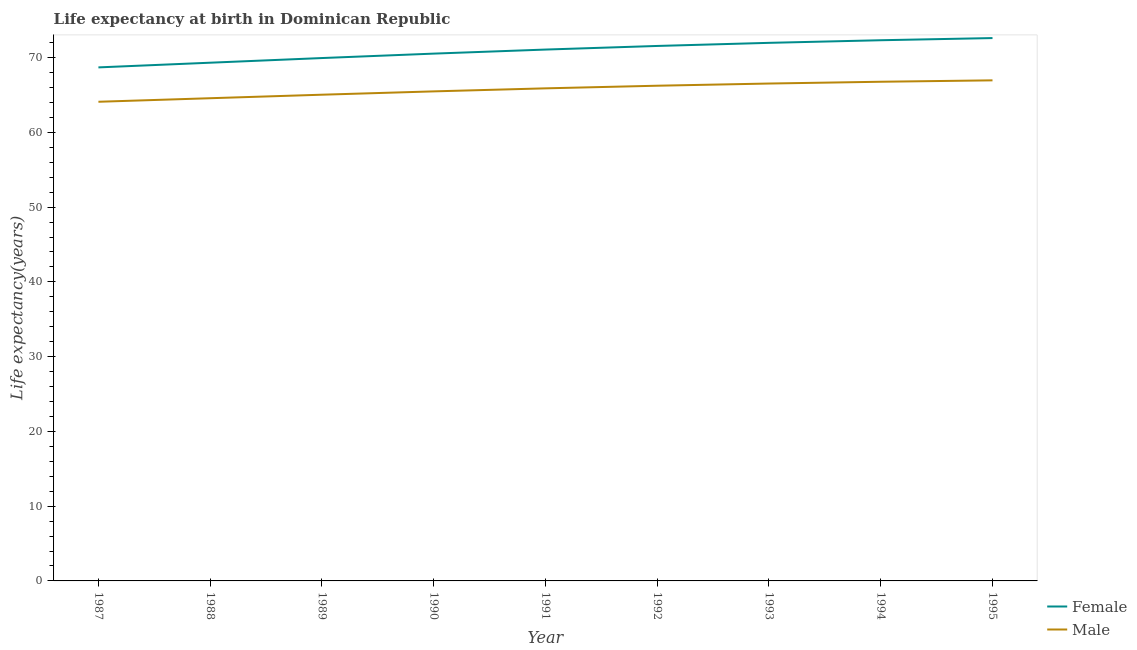How many different coloured lines are there?
Give a very brief answer. 2. Does the line corresponding to life expectancy(male) intersect with the line corresponding to life expectancy(female)?
Offer a terse response. No. What is the life expectancy(female) in 1990?
Make the answer very short. 70.54. Across all years, what is the maximum life expectancy(female)?
Your answer should be very brief. 72.62. Across all years, what is the minimum life expectancy(male)?
Make the answer very short. 64.1. What is the total life expectancy(male) in the graph?
Provide a succinct answer. 591.6. What is the difference between the life expectancy(female) in 1987 and that in 1990?
Keep it short and to the point. -1.84. What is the difference between the life expectancy(male) in 1991 and the life expectancy(female) in 1995?
Your answer should be very brief. -6.73. What is the average life expectancy(female) per year?
Offer a very short reply. 70.9. In the year 1991, what is the difference between the life expectancy(male) and life expectancy(female)?
Offer a very short reply. -5.19. In how many years, is the life expectancy(female) greater than 52 years?
Provide a short and direct response. 9. What is the ratio of the life expectancy(female) in 1987 to that in 1992?
Your answer should be compact. 0.96. Is the life expectancy(female) in 1987 less than that in 1993?
Offer a very short reply. Yes. What is the difference between the highest and the second highest life expectancy(female)?
Give a very brief answer. 0.29. What is the difference between the highest and the lowest life expectancy(female)?
Offer a very short reply. 3.92. In how many years, is the life expectancy(male) greater than the average life expectancy(male) taken over all years?
Give a very brief answer. 5. Is the life expectancy(female) strictly greater than the life expectancy(male) over the years?
Your answer should be very brief. Yes. How many years are there in the graph?
Provide a succinct answer. 9. What is the difference between two consecutive major ticks on the Y-axis?
Ensure brevity in your answer.  10. Does the graph contain any zero values?
Your response must be concise. No. Does the graph contain grids?
Keep it short and to the point. No. Where does the legend appear in the graph?
Keep it short and to the point. Bottom right. How many legend labels are there?
Keep it short and to the point. 2. What is the title of the graph?
Provide a succinct answer. Life expectancy at birth in Dominican Republic. What is the label or title of the X-axis?
Keep it short and to the point. Year. What is the label or title of the Y-axis?
Offer a terse response. Life expectancy(years). What is the Life expectancy(years) of Female in 1987?
Make the answer very short. 68.69. What is the Life expectancy(years) of Male in 1987?
Your answer should be compact. 64.1. What is the Life expectancy(years) of Female in 1988?
Provide a short and direct response. 69.32. What is the Life expectancy(years) in Male in 1988?
Provide a short and direct response. 64.57. What is the Life expectancy(years) in Female in 1989?
Offer a very short reply. 69.94. What is the Life expectancy(years) in Male in 1989?
Offer a terse response. 65.04. What is the Life expectancy(years) of Female in 1990?
Your response must be concise. 70.54. What is the Life expectancy(years) of Male in 1990?
Offer a terse response. 65.49. What is the Life expectancy(years) in Female in 1991?
Provide a succinct answer. 71.08. What is the Life expectancy(years) in Male in 1991?
Provide a succinct answer. 65.89. What is the Life expectancy(years) in Female in 1992?
Ensure brevity in your answer.  71.56. What is the Life expectancy(years) in Male in 1992?
Provide a short and direct response. 66.24. What is the Life expectancy(years) of Female in 1993?
Provide a short and direct response. 71.98. What is the Life expectancy(years) in Male in 1993?
Ensure brevity in your answer.  66.54. What is the Life expectancy(years) in Female in 1994?
Provide a short and direct response. 72.33. What is the Life expectancy(years) in Male in 1994?
Offer a terse response. 66.77. What is the Life expectancy(years) of Female in 1995?
Keep it short and to the point. 72.62. What is the Life expectancy(years) of Male in 1995?
Your answer should be compact. 66.96. Across all years, what is the maximum Life expectancy(years) of Female?
Make the answer very short. 72.62. Across all years, what is the maximum Life expectancy(years) in Male?
Offer a very short reply. 66.96. Across all years, what is the minimum Life expectancy(years) of Female?
Provide a short and direct response. 68.69. Across all years, what is the minimum Life expectancy(years) of Male?
Your answer should be compact. 64.1. What is the total Life expectancy(years) in Female in the graph?
Ensure brevity in your answer.  638.06. What is the total Life expectancy(years) of Male in the graph?
Your response must be concise. 591.6. What is the difference between the Life expectancy(years) in Female in 1987 and that in 1988?
Offer a terse response. -0.63. What is the difference between the Life expectancy(years) of Male in 1987 and that in 1988?
Keep it short and to the point. -0.47. What is the difference between the Life expectancy(years) in Female in 1987 and that in 1989?
Offer a terse response. -1.25. What is the difference between the Life expectancy(years) in Male in 1987 and that in 1989?
Offer a very short reply. -0.94. What is the difference between the Life expectancy(years) of Female in 1987 and that in 1990?
Provide a succinct answer. -1.84. What is the difference between the Life expectancy(years) of Male in 1987 and that in 1990?
Provide a short and direct response. -1.39. What is the difference between the Life expectancy(years) of Female in 1987 and that in 1991?
Your response must be concise. -2.39. What is the difference between the Life expectancy(years) of Male in 1987 and that in 1991?
Offer a very short reply. -1.79. What is the difference between the Life expectancy(years) in Female in 1987 and that in 1992?
Provide a succinct answer. -2.87. What is the difference between the Life expectancy(years) of Male in 1987 and that in 1992?
Your answer should be compact. -2.15. What is the difference between the Life expectancy(years) of Female in 1987 and that in 1993?
Give a very brief answer. -3.28. What is the difference between the Life expectancy(years) of Male in 1987 and that in 1993?
Your answer should be compact. -2.44. What is the difference between the Life expectancy(years) of Female in 1987 and that in 1994?
Keep it short and to the point. -3.63. What is the difference between the Life expectancy(years) in Male in 1987 and that in 1994?
Your answer should be compact. -2.68. What is the difference between the Life expectancy(years) of Female in 1987 and that in 1995?
Your answer should be very brief. -3.92. What is the difference between the Life expectancy(years) of Male in 1987 and that in 1995?
Your answer should be very brief. -2.87. What is the difference between the Life expectancy(years) of Female in 1988 and that in 1989?
Give a very brief answer. -0.62. What is the difference between the Life expectancy(years) of Male in 1988 and that in 1989?
Make the answer very short. -0.47. What is the difference between the Life expectancy(years) of Female in 1988 and that in 1990?
Provide a succinct answer. -1.22. What is the difference between the Life expectancy(years) in Male in 1988 and that in 1990?
Offer a terse response. -0.92. What is the difference between the Life expectancy(years) in Female in 1988 and that in 1991?
Provide a short and direct response. -1.76. What is the difference between the Life expectancy(years) in Male in 1988 and that in 1991?
Your response must be concise. -1.32. What is the difference between the Life expectancy(years) of Female in 1988 and that in 1992?
Keep it short and to the point. -2.24. What is the difference between the Life expectancy(years) in Male in 1988 and that in 1992?
Your answer should be compact. -1.67. What is the difference between the Life expectancy(years) of Female in 1988 and that in 1993?
Make the answer very short. -2.66. What is the difference between the Life expectancy(years) in Male in 1988 and that in 1993?
Ensure brevity in your answer.  -1.97. What is the difference between the Life expectancy(years) of Female in 1988 and that in 1994?
Provide a short and direct response. -3.01. What is the difference between the Life expectancy(years) of Male in 1988 and that in 1994?
Your answer should be very brief. -2.2. What is the difference between the Life expectancy(years) of Female in 1988 and that in 1995?
Provide a short and direct response. -3.3. What is the difference between the Life expectancy(years) in Male in 1988 and that in 1995?
Ensure brevity in your answer.  -2.39. What is the difference between the Life expectancy(years) in Female in 1989 and that in 1990?
Give a very brief answer. -0.59. What is the difference between the Life expectancy(years) in Male in 1989 and that in 1990?
Provide a short and direct response. -0.45. What is the difference between the Life expectancy(years) of Female in 1989 and that in 1991?
Offer a terse response. -1.14. What is the difference between the Life expectancy(years) in Male in 1989 and that in 1991?
Make the answer very short. -0.85. What is the difference between the Life expectancy(years) of Female in 1989 and that in 1992?
Provide a succinct answer. -1.62. What is the difference between the Life expectancy(years) in Male in 1989 and that in 1992?
Your response must be concise. -1.2. What is the difference between the Life expectancy(years) of Female in 1989 and that in 1993?
Ensure brevity in your answer.  -2.03. What is the difference between the Life expectancy(years) of Male in 1989 and that in 1993?
Offer a very short reply. -1.5. What is the difference between the Life expectancy(years) of Female in 1989 and that in 1994?
Provide a succinct answer. -2.38. What is the difference between the Life expectancy(years) of Male in 1989 and that in 1994?
Give a very brief answer. -1.73. What is the difference between the Life expectancy(years) in Female in 1989 and that in 1995?
Your response must be concise. -2.67. What is the difference between the Life expectancy(years) in Male in 1989 and that in 1995?
Keep it short and to the point. -1.92. What is the difference between the Life expectancy(years) in Female in 1990 and that in 1991?
Your response must be concise. -0.54. What is the difference between the Life expectancy(years) in Male in 1990 and that in 1991?
Your answer should be very brief. -0.4. What is the difference between the Life expectancy(years) in Female in 1990 and that in 1992?
Your answer should be compact. -1.02. What is the difference between the Life expectancy(years) in Male in 1990 and that in 1992?
Provide a succinct answer. -0.76. What is the difference between the Life expectancy(years) of Female in 1990 and that in 1993?
Keep it short and to the point. -1.44. What is the difference between the Life expectancy(years) in Male in 1990 and that in 1993?
Your answer should be very brief. -1.05. What is the difference between the Life expectancy(years) in Female in 1990 and that in 1994?
Provide a short and direct response. -1.79. What is the difference between the Life expectancy(years) in Male in 1990 and that in 1994?
Provide a succinct answer. -1.29. What is the difference between the Life expectancy(years) of Female in 1990 and that in 1995?
Your answer should be very brief. -2.08. What is the difference between the Life expectancy(years) in Male in 1990 and that in 1995?
Your answer should be compact. -1.47. What is the difference between the Life expectancy(years) in Female in 1991 and that in 1992?
Your response must be concise. -0.48. What is the difference between the Life expectancy(years) of Male in 1991 and that in 1992?
Provide a short and direct response. -0.35. What is the difference between the Life expectancy(years) of Female in 1991 and that in 1993?
Your answer should be very brief. -0.9. What is the difference between the Life expectancy(years) of Male in 1991 and that in 1993?
Your answer should be very brief. -0.65. What is the difference between the Life expectancy(years) of Female in 1991 and that in 1994?
Give a very brief answer. -1.25. What is the difference between the Life expectancy(years) of Male in 1991 and that in 1994?
Offer a very short reply. -0.88. What is the difference between the Life expectancy(years) of Female in 1991 and that in 1995?
Your answer should be compact. -1.54. What is the difference between the Life expectancy(years) in Male in 1991 and that in 1995?
Your answer should be very brief. -1.07. What is the difference between the Life expectancy(years) of Female in 1992 and that in 1993?
Offer a very short reply. -0.42. What is the difference between the Life expectancy(years) of Male in 1992 and that in 1993?
Provide a succinct answer. -0.29. What is the difference between the Life expectancy(years) of Female in 1992 and that in 1994?
Keep it short and to the point. -0.77. What is the difference between the Life expectancy(years) of Male in 1992 and that in 1994?
Offer a very short reply. -0.53. What is the difference between the Life expectancy(years) of Female in 1992 and that in 1995?
Keep it short and to the point. -1.06. What is the difference between the Life expectancy(years) in Male in 1992 and that in 1995?
Your response must be concise. -0.72. What is the difference between the Life expectancy(years) in Female in 1993 and that in 1994?
Offer a terse response. -0.35. What is the difference between the Life expectancy(years) of Male in 1993 and that in 1994?
Keep it short and to the point. -0.24. What is the difference between the Life expectancy(years) in Female in 1993 and that in 1995?
Give a very brief answer. -0.64. What is the difference between the Life expectancy(years) of Male in 1993 and that in 1995?
Ensure brevity in your answer.  -0.42. What is the difference between the Life expectancy(years) in Female in 1994 and that in 1995?
Ensure brevity in your answer.  -0.29. What is the difference between the Life expectancy(years) of Male in 1994 and that in 1995?
Provide a succinct answer. -0.19. What is the difference between the Life expectancy(years) in Female in 1987 and the Life expectancy(years) in Male in 1988?
Give a very brief answer. 4.12. What is the difference between the Life expectancy(years) of Female in 1987 and the Life expectancy(years) of Male in 1989?
Give a very brief answer. 3.65. What is the difference between the Life expectancy(years) of Female in 1987 and the Life expectancy(years) of Male in 1990?
Offer a very short reply. 3.21. What is the difference between the Life expectancy(years) of Female in 1987 and the Life expectancy(years) of Male in 1991?
Give a very brief answer. 2.8. What is the difference between the Life expectancy(years) of Female in 1987 and the Life expectancy(years) of Male in 1992?
Ensure brevity in your answer.  2.45. What is the difference between the Life expectancy(years) of Female in 1987 and the Life expectancy(years) of Male in 1993?
Offer a very short reply. 2.16. What is the difference between the Life expectancy(years) in Female in 1987 and the Life expectancy(years) in Male in 1994?
Offer a terse response. 1.92. What is the difference between the Life expectancy(years) in Female in 1987 and the Life expectancy(years) in Male in 1995?
Your answer should be very brief. 1.73. What is the difference between the Life expectancy(years) in Female in 1988 and the Life expectancy(years) in Male in 1989?
Ensure brevity in your answer.  4.28. What is the difference between the Life expectancy(years) of Female in 1988 and the Life expectancy(years) of Male in 1990?
Provide a short and direct response. 3.83. What is the difference between the Life expectancy(years) in Female in 1988 and the Life expectancy(years) in Male in 1991?
Give a very brief answer. 3.43. What is the difference between the Life expectancy(years) in Female in 1988 and the Life expectancy(years) in Male in 1992?
Give a very brief answer. 3.08. What is the difference between the Life expectancy(years) of Female in 1988 and the Life expectancy(years) of Male in 1993?
Make the answer very short. 2.79. What is the difference between the Life expectancy(years) in Female in 1988 and the Life expectancy(years) in Male in 1994?
Your answer should be very brief. 2.55. What is the difference between the Life expectancy(years) of Female in 1988 and the Life expectancy(years) of Male in 1995?
Your answer should be very brief. 2.36. What is the difference between the Life expectancy(years) in Female in 1989 and the Life expectancy(years) in Male in 1990?
Make the answer very short. 4.46. What is the difference between the Life expectancy(years) in Female in 1989 and the Life expectancy(years) in Male in 1991?
Your answer should be compact. 4.05. What is the difference between the Life expectancy(years) in Female in 1989 and the Life expectancy(years) in Male in 1992?
Give a very brief answer. 3.7. What is the difference between the Life expectancy(years) in Female in 1989 and the Life expectancy(years) in Male in 1993?
Ensure brevity in your answer.  3.41. What is the difference between the Life expectancy(years) in Female in 1989 and the Life expectancy(years) in Male in 1994?
Your response must be concise. 3.17. What is the difference between the Life expectancy(years) of Female in 1989 and the Life expectancy(years) of Male in 1995?
Give a very brief answer. 2.98. What is the difference between the Life expectancy(years) of Female in 1990 and the Life expectancy(years) of Male in 1991?
Offer a terse response. 4.65. What is the difference between the Life expectancy(years) in Female in 1990 and the Life expectancy(years) in Male in 1992?
Give a very brief answer. 4.29. What is the difference between the Life expectancy(years) of Female in 1990 and the Life expectancy(years) of Male in 1993?
Your answer should be compact. 4. What is the difference between the Life expectancy(years) of Female in 1990 and the Life expectancy(years) of Male in 1994?
Your response must be concise. 3.76. What is the difference between the Life expectancy(years) of Female in 1990 and the Life expectancy(years) of Male in 1995?
Keep it short and to the point. 3.58. What is the difference between the Life expectancy(years) in Female in 1991 and the Life expectancy(years) in Male in 1992?
Provide a succinct answer. 4.84. What is the difference between the Life expectancy(years) of Female in 1991 and the Life expectancy(years) of Male in 1993?
Your response must be concise. 4.54. What is the difference between the Life expectancy(years) of Female in 1991 and the Life expectancy(years) of Male in 1994?
Provide a succinct answer. 4.31. What is the difference between the Life expectancy(years) in Female in 1991 and the Life expectancy(years) in Male in 1995?
Give a very brief answer. 4.12. What is the difference between the Life expectancy(years) in Female in 1992 and the Life expectancy(years) in Male in 1993?
Keep it short and to the point. 5.03. What is the difference between the Life expectancy(years) in Female in 1992 and the Life expectancy(years) in Male in 1994?
Ensure brevity in your answer.  4.79. What is the difference between the Life expectancy(years) in Female in 1992 and the Life expectancy(years) in Male in 1995?
Your answer should be very brief. 4.6. What is the difference between the Life expectancy(years) in Female in 1993 and the Life expectancy(years) in Male in 1994?
Keep it short and to the point. 5.2. What is the difference between the Life expectancy(years) of Female in 1993 and the Life expectancy(years) of Male in 1995?
Offer a terse response. 5.02. What is the difference between the Life expectancy(years) in Female in 1994 and the Life expectancy(years) in Male in 1995?
Provide a short and direct response. 5.37. What is the average Life expectancy(years) in Female per year?
Your response must be concise. 70.9. What is the average Life expectancy(years) of Male per year?
Offer a terse response. 65.73. In the year 1987, what is the difference between the Life expectancy(years) in Female and Life expectancy(years) in Male?
Offer a very short reply. 4.6. In the year 1988, what is the difference between the Life expectancy(years) of Female and Life expectancy(years) of Male?
Your answer should be very brief. 4.75. In the year 1989, what is the difference between the Life expectancy(years) of Female and Life expectancy(years) of Male?
Your response must be concise. 4.9. In the year 1990, what is the difference between the Life expectancy(years) of Female and Life expectancy(years) of Male?
Provide a succinct answer. 5.05. In the year 1991, what is the difference between the Life expectancy(years) of Female and Life expectancy(years) of Male?
Ensure brevity in your answer.  5.19. In the year 1992, what is the difference between the Life expectancy(years) of Female and Life expectancy(years) of Male?
Offer a very short reply. 5.32. In the year 1993, what is the difference between the Life expectancy(years) of Female and Life expectancy(years) of Male?
Make the answer very short. 5.44. In the year 1994, what is the difference between the Life expectancy(years) in Female and Life expectancy(years) in Male?
Provide a short and direct response. 5.55. In the year 1995, what is the difference between the Life expectancy(years) in Female and Life expectancy(years) in Male?
Make the answer very short. 5.66. What is the ratio of the Life expectancy(years) of Female in 1987 to that in 1988?
Your answer should be compact. 0.99. What is the ratio of the Life expectancy(years) in Male in 1987 to that in 1988?
Offer a terse response. 0.99. What is the ratio of the Life expectancy(years) in Female in 1987 to that in 1989?
Make the answer very short. 0.98. What is the ratio of the Life expectancy(years) of Male in 1987 to that in 1989?
Your answer should be very brief. 0.99. What is the ratio of the Life expectancy(years) of Female in 1987 to that in 1990?
Your answer should be very brief. 0.97. What is the ratio of the Life expectancy(years) in Male in 1987 to that in 1990?
Provide a short and direct response. 0.98. What is the ratio of the Life expectancy(years) in Female in 1987 to that in 1991?
Offer a terse response. 0.97. What is the ratio of the Life expectancy(years) in Male in 1987 to that in 1991?
Provide a short and direct response. 0.97. What is the ratio of the Life expectancy(years) of Female in 1987 to that in 1992?
Give a very brief answer. 0.96. What is the ratio of the Life expectancy(years) of Male in 1987 to that in 1992?
Your response must be concise. 0.97. What is the ratio of the Life expectancy(years) of Female in 1987 to that in 1993?
Your answer should be very brief. 0.95. What is the ratio of the Life expectancy(years) of Male in 1987 to that in 1993?
Provide a succinct answer. 0.96. What is the ratio of the Life expectancy(years) in Female in 1987 to that in 1994?
Give a very brief answer. 0.95. What is the ratio of the Life expectancy(years) of Male in 1987 to that in 1994?
Your response must be concise. 0.96. What is the ratio of the Life expectancy(years) of Female in 1987 to that in 1995?
Ensure brevity in your answer.  0.95. What is the ratio of the Life expectancy(years) of Male in 1987 to that in 1995?
Your answer should be compact. 0.96. What is the ratio of the Life expectancy(years) of Female in 1988 to that in 1989?
Your answer should be very brief. 0.99. What is the ratio of the Life expectancy(years) of Female in 1988 to that in 1990?
Offer a very short reply. 0.98. What is the ratio of the Life expectancy(years) in Male in 1988 to that in 1990?
Give a very brief answer. 0.99. What is the ratio of the Life expectancy(years) of Female in 1988 to that in 1991?
Your answer should be very brief. 0.98. What is the ratio of the Life expectancy(years) of Male in 1988 to that in 1991?
Your response must be concise. 0.98. What is the ratio of the Life expectancy(years) of Female in 1988 to that in 1992?
Your response must be concise. 0.97. What is the ratio of the Life expectancy(years) in Male in 1988 to that in 1992?
Offer a very short reply. 0.97. What is the ratio of the Life expectancy(years) of Female in 1988 to that in 1993?
Keep it short and to the point. 0.96. What is the ratio of the Life expectancy(years) in Male in 1988 to that in 1993?
Your response must be concise. 0.97. What is the ratio of the Life expectancy(years) of Female in 1988 to that in 1994?
Give a very brief answer. 0.96. What is the ratio of the Life expectancy(years) of Male in 1988 to that in 1994?
Provide a short and direct response. 0.97. What is the ratio of the Life expectancy(years) in Female in 1988 to that in 1995?
Provide a succinct answer. 0.95. What is the ratio of the Life expectancy(years) of Male in 1988 to that in 1995?
Give a very brief answer. 0.96. What is the ratio of the Life expectancy(years) in Male in 1989 to that in 1990?
Provide a short and direct response. 0.99. What is the ratio of the Life expectancy(years) of Female in 1989 to that in 1991?
Offer a very short reply. 0.98. What is the ratio of the Life expectancy(years) of Male in 1989 to that in 1991?
Your answer should be very brief. 0.99. What is the ratio of the Life expectancy(years) in Female in 1989 to that in 1992?
Your response must be concise. 0.98. What is the ratio of the Life expectancy(years) in Male in 1989 to that in 1992?
Your response must be concise. 0.98. What is the ratio of the Life expectancy(years) of Female in 1989 to that in 1993?
Your answer should be very brief. 0.97. What is the ratio of the Life expectancy(years) in Male in 1989 to that in 1993?
Offer a terse response. 0.98. What is the ratio of the Life expectancy(years) in Female in 1989 to that in 1995?
Offer a very short reply. 0.96. What is the ratio of the Life expectancy(years) of Male in 1989 to that in 1995?
Ensure brevity in your answer.  0.97. What is the ratio of the Life expectancy(years) in Female in 1990 to that in 1991?
Your response must be concise. 0.99. What is the ratio of the Life expectancy(years) of Male in 1990 to that in 1991?
Offer a terse response. 0.99. What is the ratio of the Life expectancy(years) of Female in 1990 to that in 1992?
Provide a succinct answer. 0.99. What is the ratio of the Life expectancy(years) in Male in 1990 to that in 1992?
Your response must be concise. 0.99. What is the ratio of the Life expectancy(years) in Female in 1990 to that in 1993?
Your response must be concise. 0.98. What is the ratio of the Life expectancy(years) in Male in 1990 to that in 1993?
Make the answer very short. 0.98. What is the ratio of the Life expectancy(years) in Female in 1990 to that in 1994?
Provide a short and direct response. 0.98. What is the ratio of the Life expectancy(years) of Male in 1990 to that in 1994?
Ensure brevity in your answer.  0.98. What is the ratio of the Life expectancy(years) in Female in 1990 to that in 1995?
Offer a terse response. 0.97. What is the ratio of the Life expectancy(years) in Female in 1991 to that in 1992?
Ensure brevity in your answer.  0.99. What is the ratio of the Life expectancy(years) of Female in 1991 to that in 1993?
Give a very brief answer. 0.99. What is the ratio of the Life expectancy(years) in Male in 1991 to that in 1993?
Offer a terse response. 0.99. What is the ratio of the Life expectancy(years) in Female in 1991 to that in 1994?
Your answer should be very brief. 0.98. What is the ratio of the Life expectancy(years) of Female in 1991 to that in 1995?
Your response must be concise. 0.98. What is the ratio of the Life expectancy(years) of Male in 1991 to that in 1995?
Ensure brevity in your answer.  0.98. What is the ratio of the Life expectancy(years) in Female in 1992 to that in 1993?
Make the answer very short. 0.99. What is the ratio of the Life expectancy(years) of Female in 1992 to that in 1994?
Provide a succinct answer. 0.99. What is the ratio of the Life expectancy(years) in Male in 1992 to that in 1994?
Your response must be concise. 0.99. What is the ratio of the Life expectancy(years) of Female in 1992 to that in 1995?
Your answer should be compact. 0.99. What is the ratio of the Life expectancy(years) in Male in 1992 to that in 1995?
Keep it short and to the point. 0.99. What is the ratio of the Life expectancy(years) of Female in 1993 to that in 1994?
Offer a very short reply. 1. What is the ratio of the Life expectancy(years) in Female in 1993 to that in 1995?
Make the answer very short. 0.99. What is the ratio of the Life expectancy(years) of Female in 1994 to that in 1995?
Ensure brevity in your answer.  1. What is the difference between the highest and the second highest Life expectancy(years) in Female?
Your answer should be compact. 0.29. What is the difference between the highest and the second highest Life expectancy(years) of Male?
Give a very brief answer. 0.19. What is the difference between the highest and the lowest Life expectancy(years) in Female?
Offer a very short reply. 3.92. What is the difference between the highest and the lowest Life expectancy(years) of Male?
Keep it short and to the point. 2.87. 